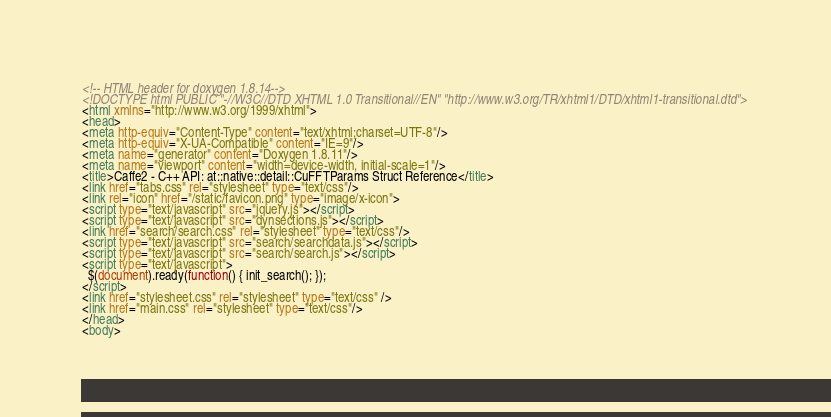<code> <loc_0><loc_0><loc_500><loc_500><_HTML_><!-- HTML header for doxygen 1.8.14-->
<!DOCTYPE html PUBLIC "-//W3C//DTD XHTML 1.0 Transitional//EN" "http://www.w3.org/TR/xhtml1/DTD/xhtml1-transitional.dtd">
<html xmlns="http://www.w3.org/1999/xhtml">
<head>
<meta http-equiv="Content-Type" content="text/xhtml;charset=UTF-8"/>
<meta http-equiv="X-UA-Compatible" content="IE=9"/>
<meta name="generator" content="Doxygen 1.8.11"/>
<meta name="viewport" content="width=device-width, initial-scale=1"/>
<title>Caffe2 - C++ API: at::native::detail::CuFFTParams Struct Reference</title>
<link href="tabs.css" rel="stylesheet" type="text/css"/>
<link rel="icon" href="/static/favicon.png" type="image/x-icon">
<script type="text/javascript" src="jquery.js"></script>
<script type="text/javascript" src="dynsections.js"></script>
<link href="search/search.css" rel="stylesheet" type="text/css"/>
<script type="text/javascript" src="search/searchdata.js"></script>
<script type="text/javascript" src="search/search.js"></script>
<script type="text/javascript">
  $(document).ready(function() { init_search(); });
</script>
<link href="stylesheet.css" rel="stylesheet" type="text/css" />
<link href="main.css" rel="stylesheet" type="text/css"/>
</head>
<body></code> 